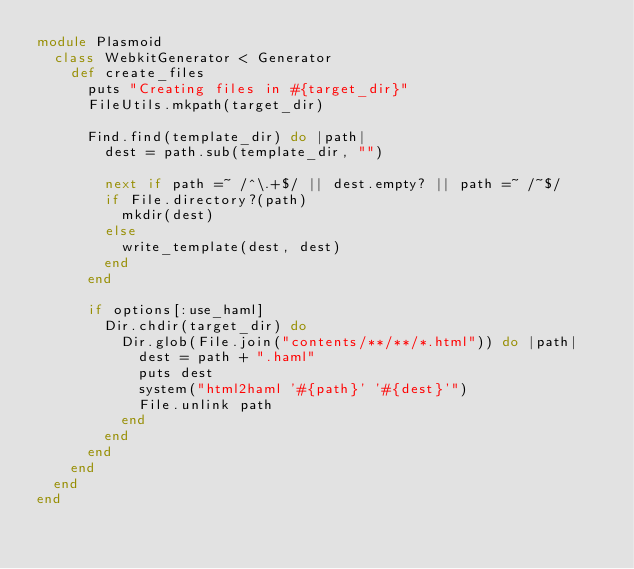<code> <loc_0><loc_0><loc_500><loc_500><_Ruby_>module Plasmoid
  class WebkitGenerator < Generator
    def create_files
      puts "Creating files in #{target_dir}"
      FileUtils.mkpath(target_dir)

      Find.find(template_dir) do |path|
        dest = path.sub(template_dir, "")

        next if path =~ /^\.+$/ || dest.empty? || path =~ /~$/
        if File.directory?(path)
          mkdir(dest)
        else
          write_template(dest, dest)
        end
      end

      if options[:use_haml]
        Dir.chdir(target_dir) do
          Dir.glob(File.join("contents/**/**/*.html")) do |path|
            dest = path + ".haml"
            puts dest
            system("html2haml '#{path}' '#{dest}'")
            File.unlink path
          end
        end
      end
    end
  end
end
</code> 